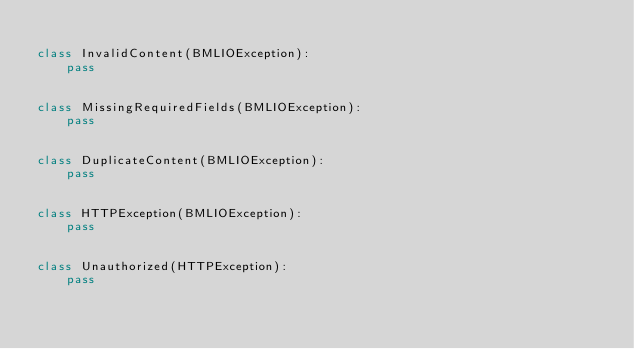Convert code to text. <code><loc_0><loc_0><loc_500><loc_500><_Python_>
class InvalidContent(BMLIOException):
    pass


class MissingRequiredFields(BMLIOException):
    pass


class DuplicateContent(BMLIOException):
    pass


class HTTPException(BMLIOException):
    pass


class Unauthorized(HTTPException):
    pass
</code> 